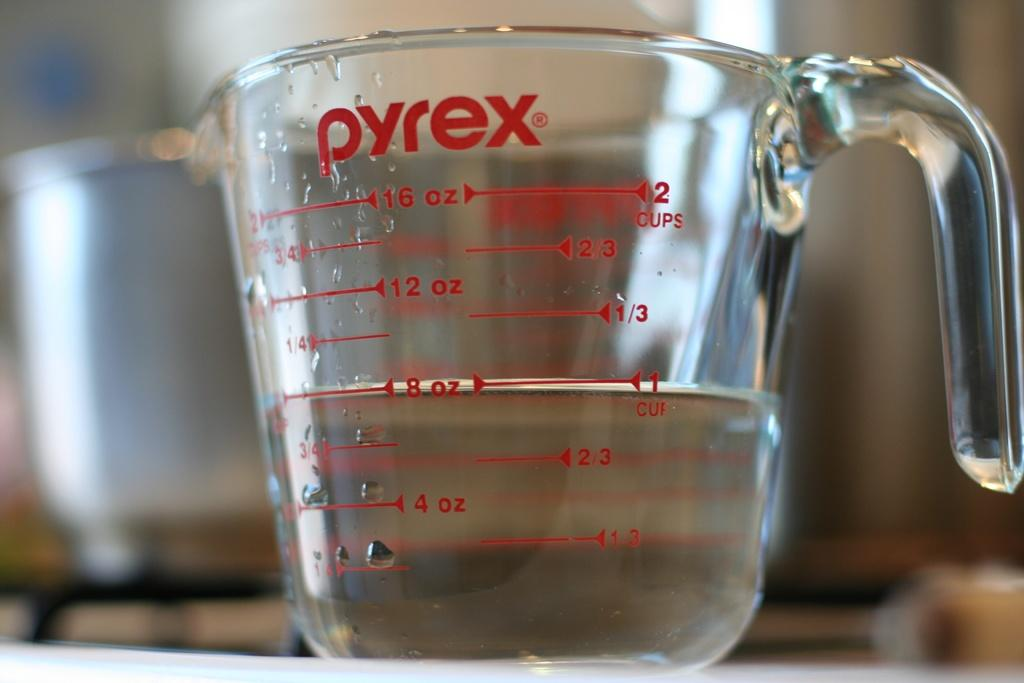<image>
Share a concise interpretation of the image provided. A jug by a brand called Pyrex which measures liquid in ounces. 